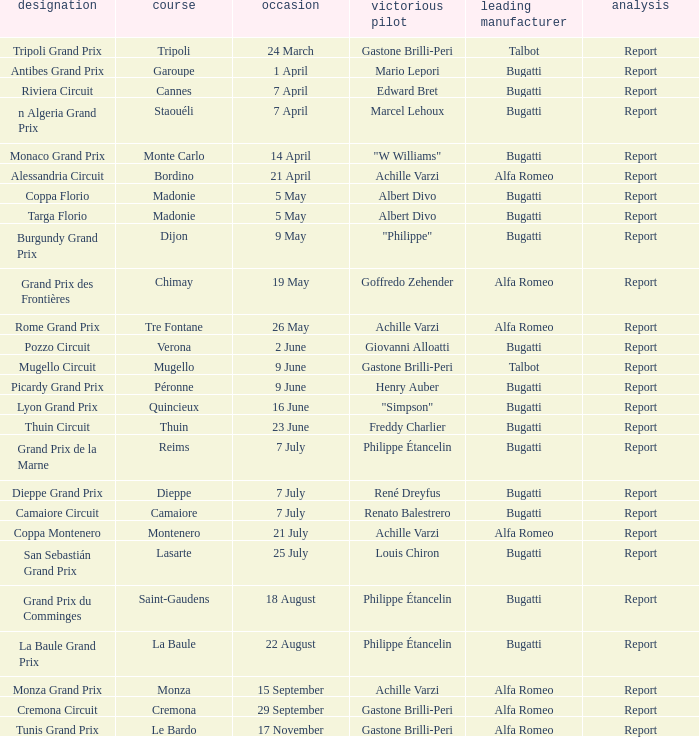What Name has a Winning constructor of bugatti, and a Winning driver of louis chiron? San Sebastián Grand Prix. 